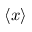<formula> <loc_0><loc_0><loc_500><loc_500>\left \langle { x } \right \rangle</formula> 